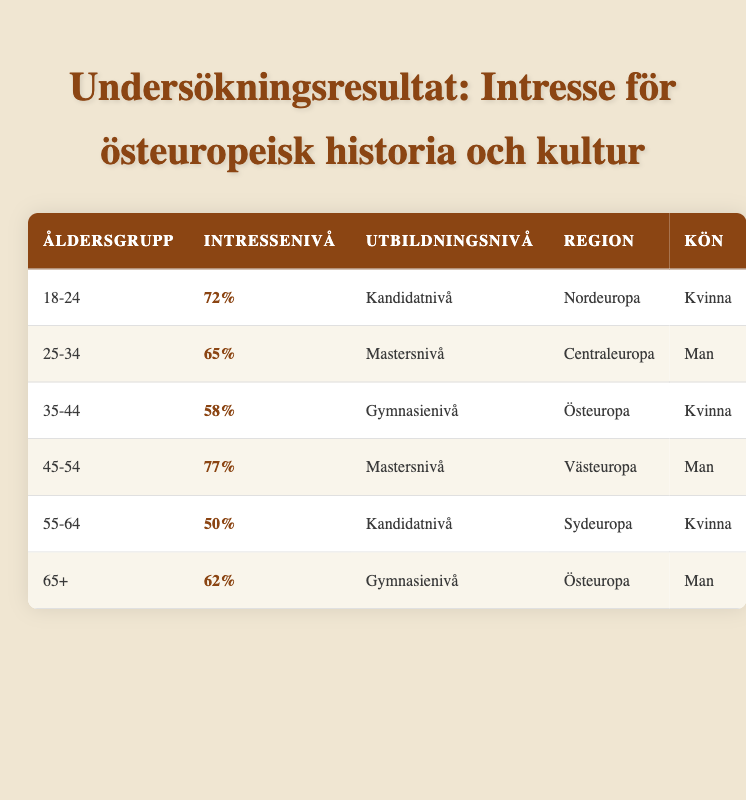What is the interest level for the age group 18-24? The table shows that the interest level for the age group 18-24 is 72%.
Answer: 72% Which education level has the highest interest level? Looking through the table, the highest interest level is 77%, which corresponds to the "Postgraduate" education level for the age group 45-54.
Answer: Postgraduate Is the interest level for men in the age group 65+ higher than that of women in the age group 35-44? The interest level for men in the age group 65+ is 62%, while for women in the age group 35-44, it is 58%. Since 62% is greater than 58%, the statement is true.
Answer: Yes What is the average interest level of respondents from Eastern Europe? The interest levels from Eastern Europe are 58% (women 35-44) and 62% (men 65+). The average is calculated as (58 + 62) / 2 = 120 / 2 = 60%.
Answer: 60% How many respondents have an interest level above 70%? The respondents with interest levels above 70% are from the age groups 18-24 (72%) and 45-54 (77%). Thus, there are 2 respondents with interest levels above 70%.
Answer: 2 What is the interest level difference between the oldest and youngest age groups? The interest level for the age group 18-24 is 72%, while for the age group 65+, it is 62%. The difference is 72% - 62% = 10%.
Answer: 10% Are there more female respondents than male respondents with an interest level below 60%? The female respondents with interest levels below 60% are in the age group 35-44 (58%) and 55-64 (50%). The male respondents with interest levels below 60% are in the age group 65+ (62%), which is not below 60%. So, there are 2 female respondents and 0 male respondents. Therefore, the answer is yes, there are more female respondents.
Answer: Yes 